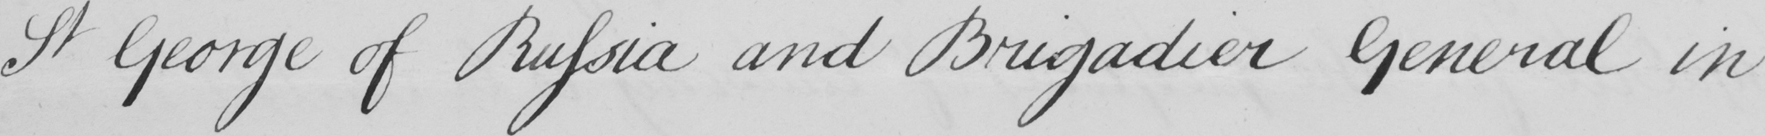What text is written in this handwritten line? St George of Russia and Brigadier General in 